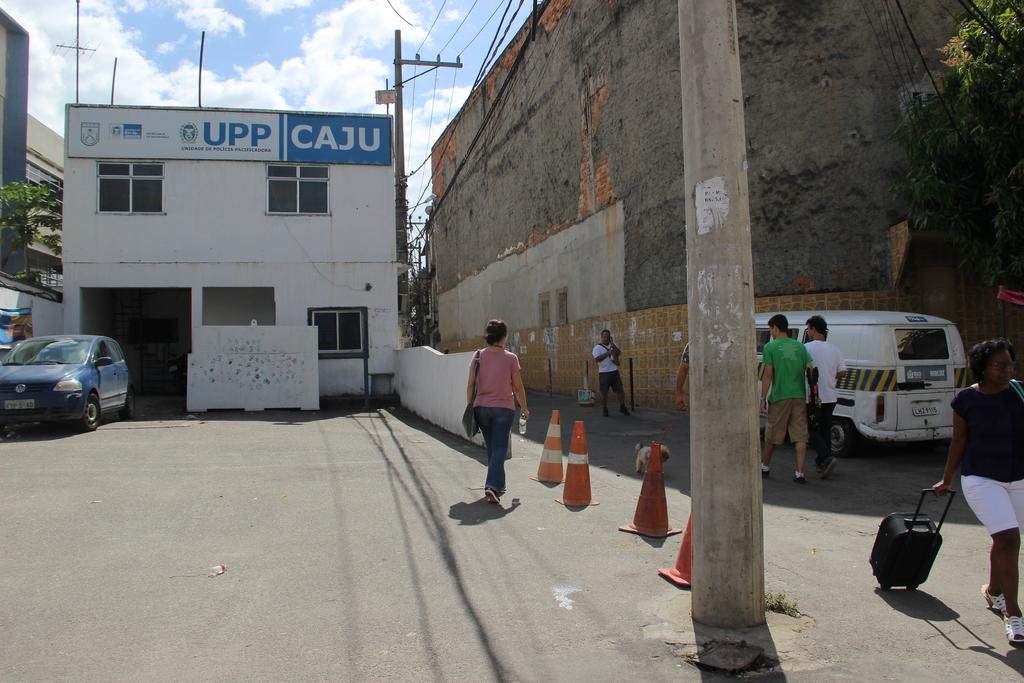<image>
Provide a brief description of the given image. A concrete streete near a building with the logo for Caju hanging of the top of the building. 